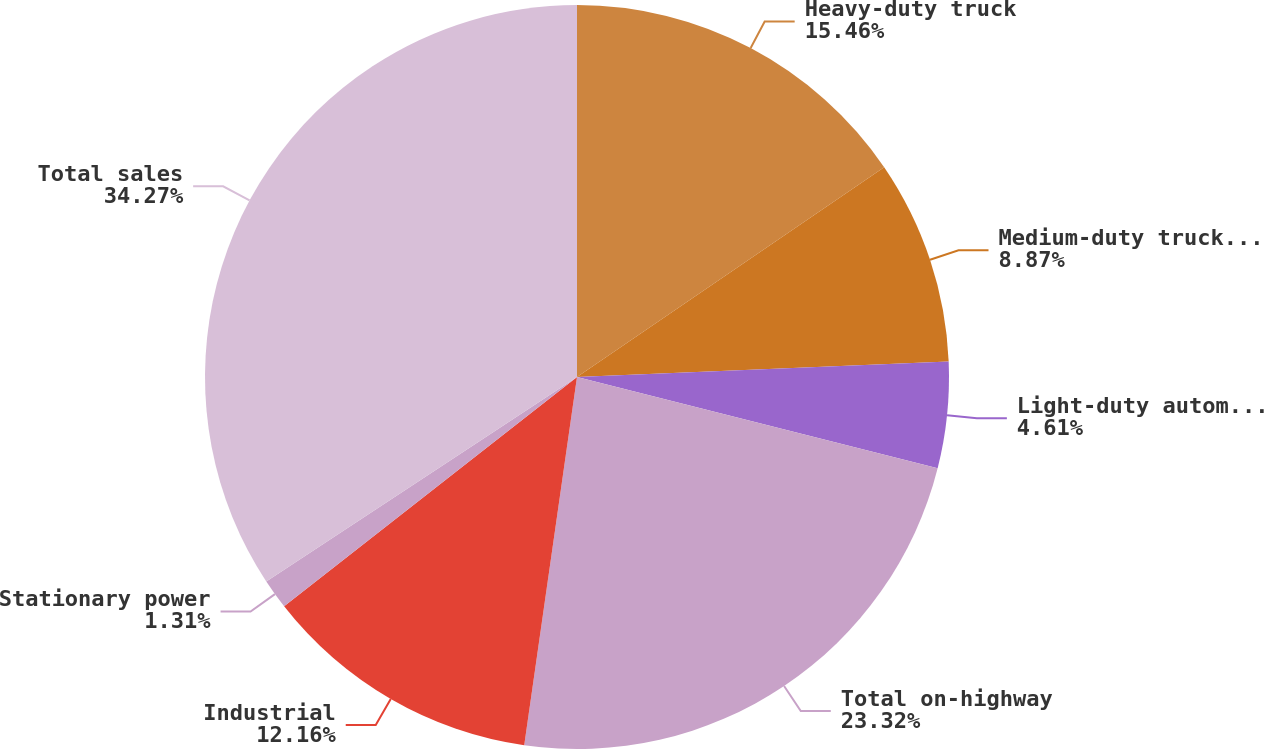<chart> <loc_0><loc_0><loc_500><loc_500><pie_chart><fcel>Heavy-duty truck<fcel>Medium-duty truck and bus<fcel>Light-duty automotive and RV<fcel>Total on-highway<fcel>Industrial<fcel>Stationary power<fcel>Total sales<nl><fcel>15.46%<fcel>8.87%<fcel>4.61%<fcel>23.32%<fcel>12.16%<fcel>1.31%<fcel>34.26%<nl></chart> 